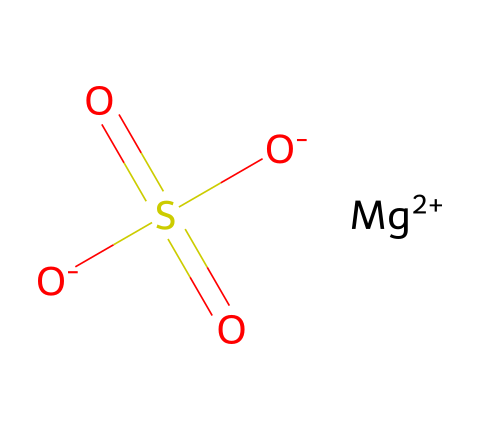What is the chemical name of this compound? The SMILES representation indicates the presence of magnesium (Mg), sulfur (S), and oxygen (O) atoms, which is characteristic of magnesium sulfate.
Answer: magnesium sulfate How many oxygen atoms are present in the structure? Analyzing the SMILES, we see "O-...O" appears twice among the bonds, indicating there are four oxygen atoms in total.
Answer: 4 What is the charge of the magnesium ion in this compound? The notation "[Mg+2]" in the SMILES indicates that the magnesium ion carries a +2 charge.
Answer: +2 What is the functional group present in magnesium sulfate? The presence of the sulfonyl group "S(=O)(=O)" indicates that the compound contains a sulfonate functional group.
Answer: sulfonate What type of chemical compound is magnesium sulfate? Given its structure, magnesium sulfate is classified as an inorganic electrolyte, commonly used to correct electrolyte imbalances.
Answer: inorganic electrolyte Why is magnesium sulfate used in medical treatments? Magnesium sulfate has properties that help treat conditions caused by low magnesium levels, as seen with its ionic structure that aids in rebalancing electrolytes.
Answer: rebalancing electrolytes 